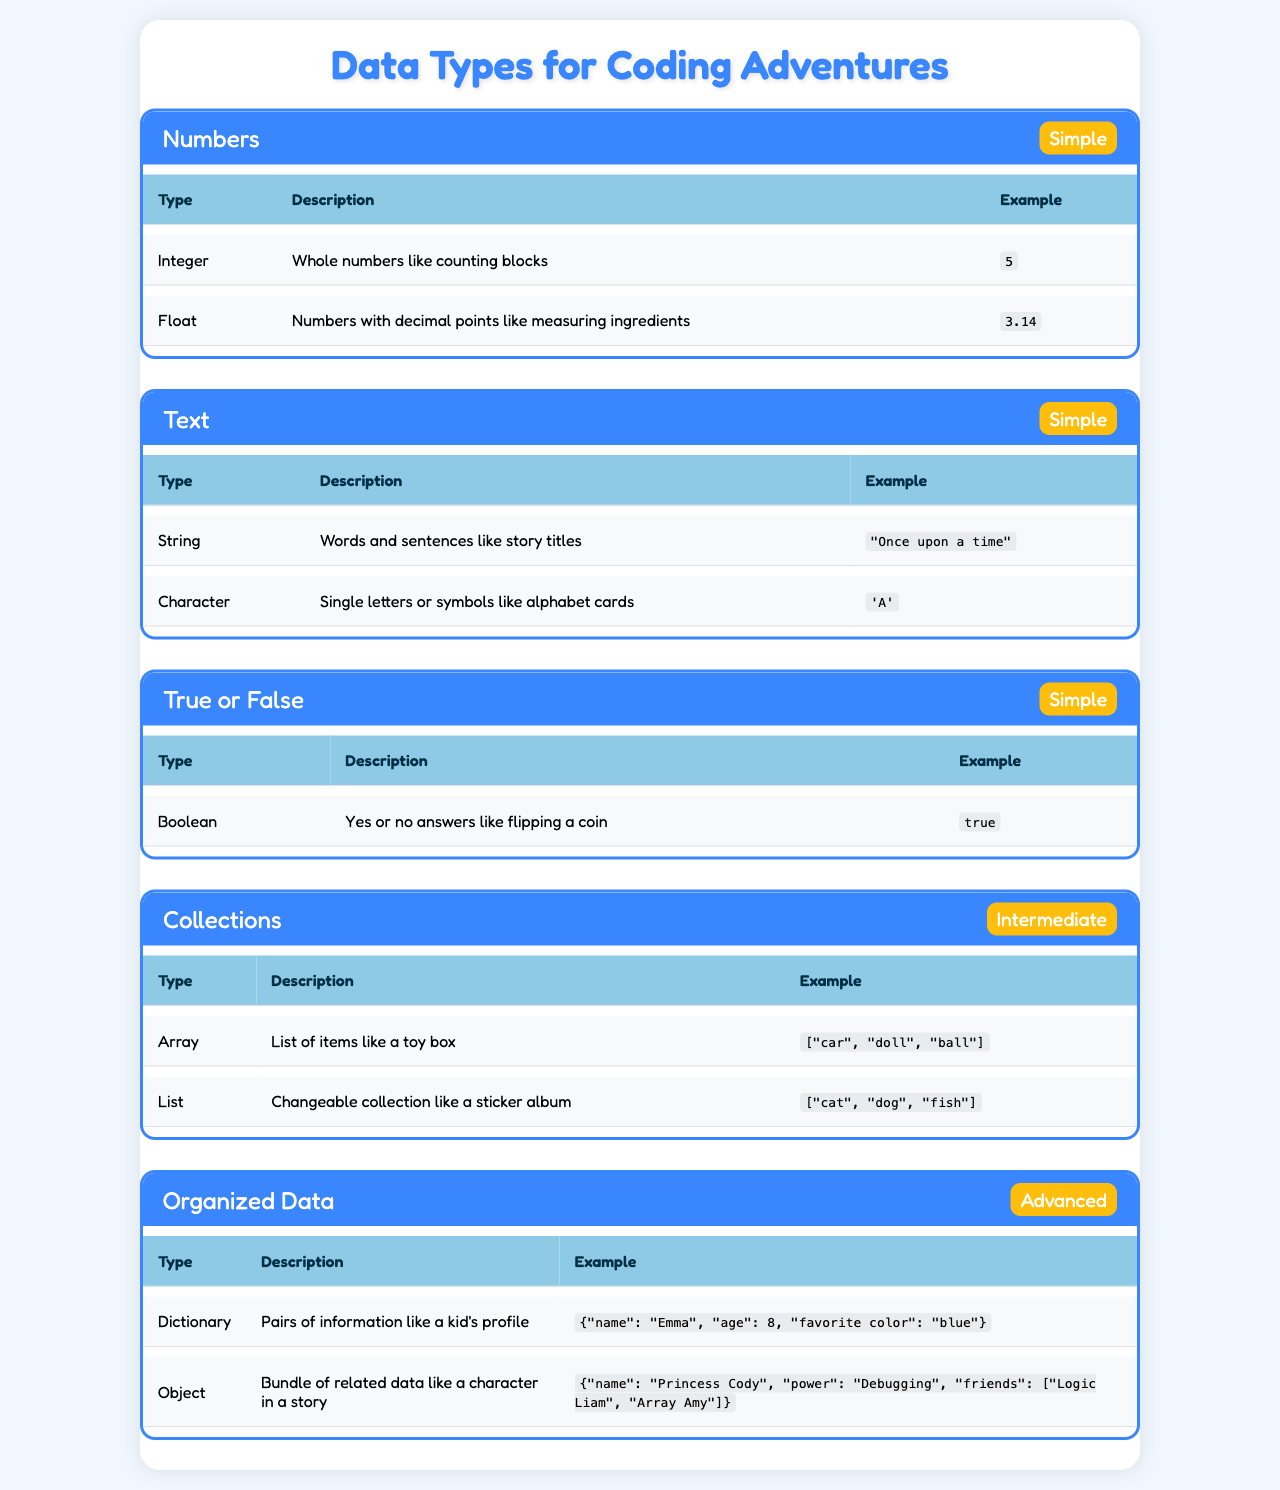What are the two types of numbers in the table? The table lists numbers as a category and specifies two types under it: Integer and Float.
Answer: Integer and Float Which data type represents words and sentences? The table indicates that the String data type is used for words and sentences, shown in the Text category.
Answer: String How many data types are in the Organized Data category? In the Organized Data category, there are two types: Dictionary and Object, as mentioned in the table.
Answer: 2 Is the Boolean data type simple or advanced? The table categorizes Boolean as simple, which means it requires basic understanding compared to other types.
Answer: Simple What is the complexity level of the Array type? The table displays the Array type under the Collections category, which is labeled as Intermediate in complexity.
Answer: Intermediate What do Integer and Float have in common regarding their category? Both Integer and Float belong to the Numbers category, which is specified in the table for data types.
Answer: Numbers If you had to list all types under the Collections category, what would they be? According to the table, the types listed under Collections are Array and List, so those are the two.
Answer: Array and List How many more types are there in the Organized Data category compared to the True or False category? The Organized Data category has two types (Dictionary and Object), while the True or False category has one type (Boolean). Thus, 2 - 1 = 1.
Answer: 1 What description relates to the List type? The table states that a List is a changeable collection, like a sticker album, showing what it represents.
Answer: Changeable collection Which category has the highest complexity level? The table categorizes Organized Data as having the highest complexity level, which is Advanced, compared to other categories.
Answer: Advanced What example is given for the Object data type? The table provides an example for the Object data type as a bundle of related data, showing an example of a character in a story.
Answer: {"name": "Princess Cody", "power": "Debugging", "friends": ["Logic Liam", "Array Amy"]} What do the complexity levels for Numbers and Text categories have in common? Both categories are labeled as Simple, indicating they require a basic understanding and are easier to learn.
Answer: Simple 